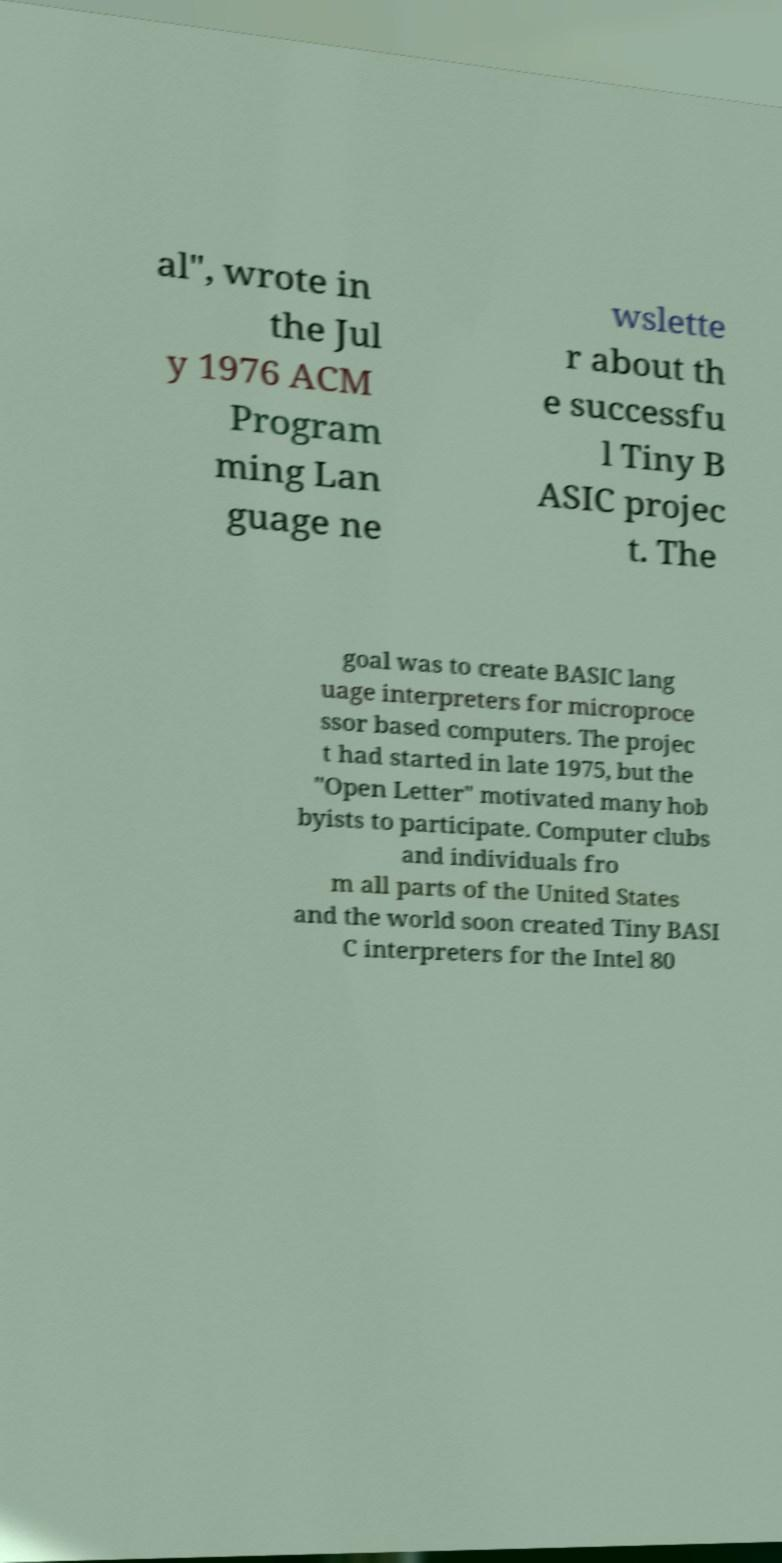Please identify and transcribe the text found in this image. al", wrote in the Jul y 1976 ACM Program ming Lan guage ne wslette r about th e successfu l Tiny B ASIC projec t. The goal was to create BASIC lang uage interpreters for microproce ssor based computers. The projec t had started in late 1975, but the "Open Letter" motivated many hob byists to participate. Computer clubs and individuals fro m all parts of the United States and the world soon created Tiny BASI C interpreters for the Intel 80 